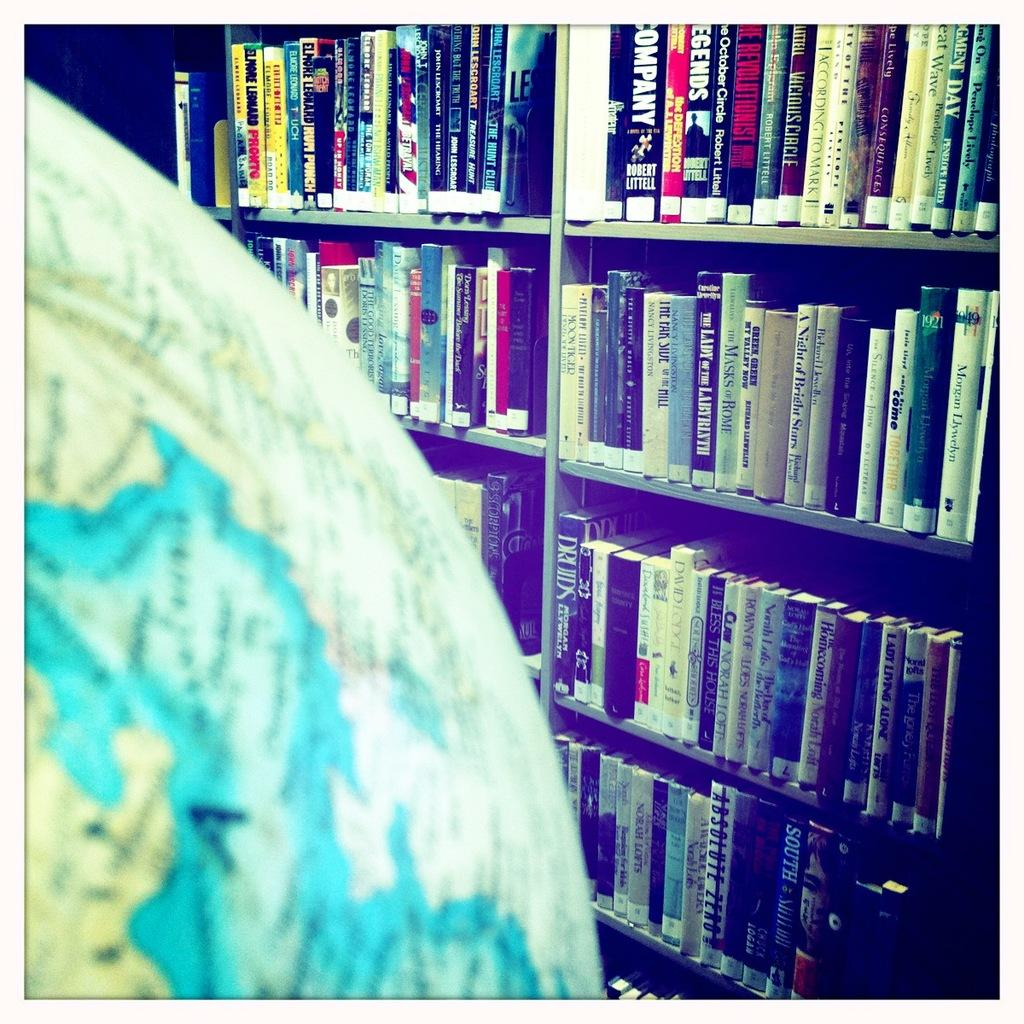<image>
Summarize the visual content of the image. The book Absolute Zero can be found on the bottom shelf across from the globe. 